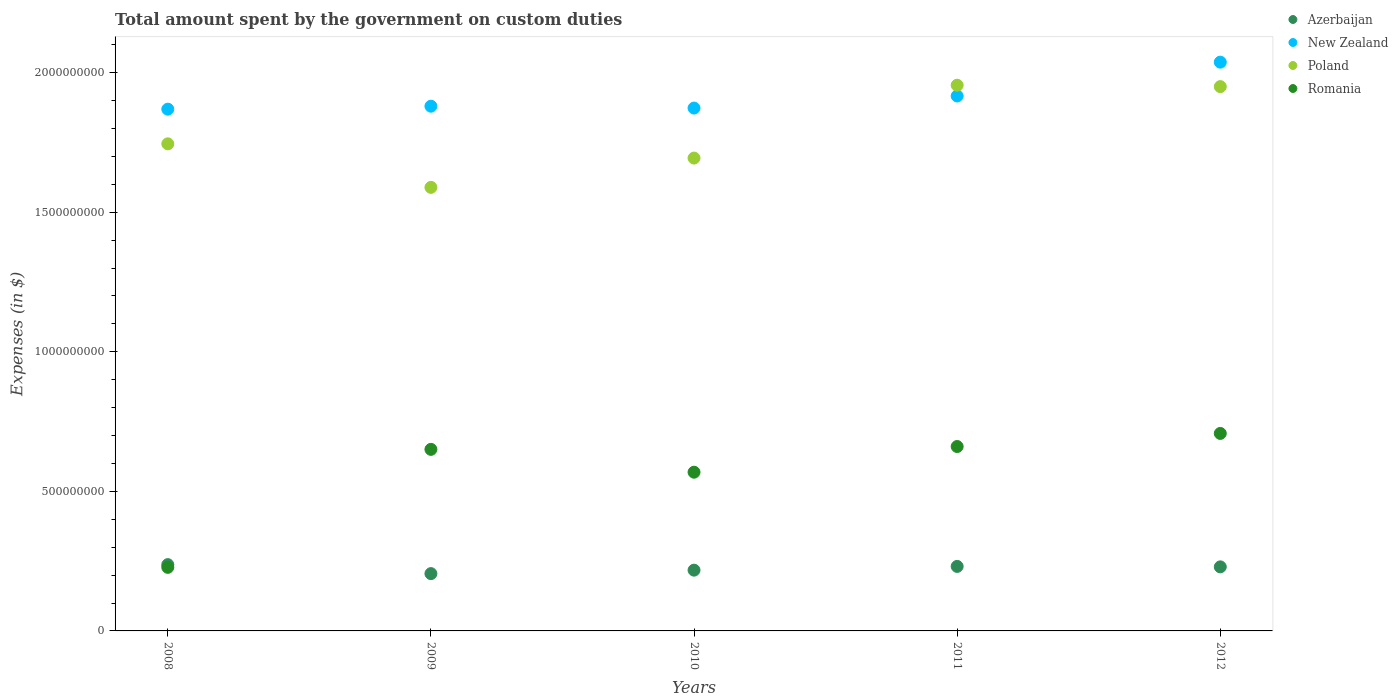Is the number of dotlines equal to the number of legend labels?
Keep it short and to the point. Yes. What is the amount spent on custom duties by the government in Romania in 2010?
Provide a succinct answer. 5.69e+08. Across all years, what is the maximum amount spent on custom duties by the government in New Zealand?
Give a very brief answer. 2.04e+09. Across all years, what is the minimum amount spent on custom duties by the government in Poland?
Your answer should be compact. 1.59e+09. In which year was the amount spent on custom duties by the government in Poland minimum?
Provide a succinct answer. 2009. What is the total amount spent on custom duties by the government in Azerbaijan in the graph?
Offer a terse response. 1.12e+09. What is the difference between the amount spent on custom duties by the government in Romania in 2008 and that in 2012?
Your response must be concise. -4.80e+08. What is the difference between the amount spent on custom duties by the government in New Zealand in 2011 and the amount spent on custom duties by the government in Romania in 2012?
Your answer should be very brief. 1.21e+09. What is the average amount spent on custom duties by the government in New Zealand per year?
Provide a short and direct response. 1.92e+09. In the year 2011, what is the difference between the amount spent on custom duties by the government in Romania and amount spent on custom duties by the government in Azerbaijan?
Your answer should be compact. 4.30e+08. In how many years, is the amount spent on custom duties by the government in New Zealand greater than 700000000 $?
Give a very brief answer. 5. What is the ratio of the amount spent on custom duties by the government in Romania in 2009 to that in 2011?
Provide a short and direct response. 0.98. What is the difference between the highest and the second highest amount spent on custom duties by the government in Azerbaijan?
Your answer should be very brief. 6.40e+06. What is the difference between the highest and the lowest amount spent on custom duties by the government in Romania?
Your response must be concise. 4.80e+08. Is it the case that in every year, the sum of the amount spent on custom duties by the government in Poland and amount spent on custom duties by the government in New Zealand  is greater than the amount spent on custom duties by the government in Romania?
Your response must be concise. Yes. How many dotlines are there?
Keep it short and to the point. 4. How many years are there in the graph?
Offer a very short reply. 5. Does the graph contain any zero values?
Keep it short and to the point. No. Does the graph contain grids?
Your response must be concise. No. What is the title of the graph?
Your answer should be compact. Total amount spent by the government on custom duties. Does "United Kingdom" appear as one of the legend labels in the graph?
Provide a short and direct response. No. What is the label or title of the X-axis?
Give a very brief answer. Years. What is the label or title of the Y-axis?
Provide a succinct answer. Expenses (in $). What is the Expenses (in $) of Azerbaijan in 2008?
Keep it short and to the point. 2.38e+08. What is the Expenses (in $) of New Zealand in 2008?
Offer a terse response. 1.87e+09. What is the Expenses (in $) in Poland in 2008?
Offer a very short reply. 1.74e+09. What is the Expenses (in $) of Romania in 2008?
Make the answer very short. 2.28e+08. What is the Expenses (in $) in Azerbaijan in 2009?
Give a very brief answer. 2.05e+08. What is the Expenses (in $) in New Zealand in 2009?
Make the answer very short. 1.88e+09. What is the Expenses (in $) in Poland in 2009?
Offer a terse response. 1.59e+09. What is the Expenses (in $) in Romania in 2009?
Offer a very short reply. 6.50e+08. What is the Expenses (in $) in Azerbaijan in 2010?
Provide a succinct answer. 2.18e+08. What is the Expenses (in $) of New Zealand in 2010?
Make the answer very short. 1.87e+09. What is the Expenses (in $) in Poland in 2010?
Your response must be concise. 1.69e+09. What is the Expenses (in $) of Romania in 2010?
Provide a short and direct response. 5.69e+08. What is the Expenses (in $) of Azerbaijan in 2011?
Give a very brief answer. 2.31e+08. What is the Expenses (in $) of New Zealand in 2011?
Offer a terse response. 1.92e+09. What is the Expenses (in $) in Poland in 2011?
Ensure brevity in your answer.  1.96e+09. What is the Expenses (in $) of Romania in 2011?
Give a very brief answer. 6.61e+08. What is the Expenses (in $) of Azerbaijan in 2012?
Your answer should be compact. 2.30e+08. What is the Expenses (in $) in New Zealand in 2012?
Give a very brief answer. 2.04e+09. What is the Expenses (in $) in Poland in 2012?
Your answer should be compact. 1.95e+09. What is the Expenses (in $) of Romania in 2012?
Offer a terse response. 7.08e+08. Across all years, what is the maximum Expenses (in $) in Azerbaijan?
Make the answer very short. 2.38e+08. Across all years, what is the maximum Expenses (in $) in New Zealand?
Provide a succinct answer. 2.04e+09. Across all years, what is the maximum Expenses (in $) in Poland?
Provide a short and direct response. 1.96e+09. Across all years, what is the maximum Expenses (in $) of Romania?
Your answer should be very brief. 7.08e+08. Across all years, what is the minimum Expenses (in $) in Azerbaijan?
Provide a succinct answer. 2.05e+08. Across all years, what is the minimum Expenses (in $) in New Zealand?
Your answer should be very brief. 1.87e+09. Across all years, what is the minimum Expenses (in $) of Poland?
Ensure brevity in your answer.  1.59e+09. Across all years, what is the minimum Expenses (in $) in Romania?
Make the answer very short. 2.28e+08. What is the total Expenses (in $) in Azerbaijan in the graph?
Give a very brief answer. 1.12e+09. What is the total Expenses (in $) of New Zealand in the graph?
Keep it short and to the point. 9.58e+09. What is the total Expenses (in $) of Poland in the graph?
Your answer should be very brief. 8.93e+09. What is the total Expenses (in $) of Romania in the graph?
Keep it short and to the point. 2.81e+09. What is the difference between the Expenses (in $) in Azerbaijan in 2008 and that in 2009?
Ensure brevity in your answer.  3.22e+07. What is the difference between the Expenses (in $) in New Zealand in 2008 and that in 2009?
Your answer should be very brief. -1.07e+07. What is the difference between the Expenses (in $) in Poland in 2008 and that in 2009?
Your answer should be very brief. 1.56e+08. What is the difference between the Expenses (in $) in Romania in 2008 and that in 2009?
Provide a short and direct response. -4.23e+08. What is the difference between the Expenses (in $) in Azerbaijan in 2008 and that in 2010?
Give a very brief answer. 1.98e+07. What is the difference between the Expenses (in $) of New Zealand in 2008 and that in 2010?
Your response must be concise. -3.96e+06. What is the difference between the Expenses (in $) of Poland in 2008 and that in 2010?
Your response must be concise. 5.10e+07. What is the difference between the Expenses (in $) in Romania in 2008 and that in 2010?
Your answer should be very brief. -3.41e+08. What is the difference between the Expenses (in $) in Azerbaijan in 2008 and that in 2011?
Give a very brief answer. 6.40e+06. What is the difference between the Expenses (in $) in New Zealand in 2008 and that in 2011?
Keep it short and to the point. -4.72e+07. What is the difference between the Expenses (in $) of Poland in 2008 and that in 2011?
Provide a succinct answer. -2.10e+08. What is the difference between the Expenses (in $) of Romania in 2008 and that in 2011?
Offer a very short reply. -4.33e+08. What is the difference between the Expenses (in $) of New Zealand in 2008 and that in 2012?
Make the answer very short. -1.68e+08. What is the difference between the Expenses (in $) of Poland in 2008 and that in 2012?
Offer a very short reply. -2.05e+08. What is the difference between the Expenses (in $) in Romania in 2008 and that in 2012?
Keep it short and to the point. -4.80e+08. What is the difference between the Expenses (in $) of Azerbaijan in 2009 and that in 2010?
Keep it short and to the point. -1.24e+07. What is the difference between the Expenses (in $) of New Zealand in 2009 and that in 2010?
Your answer should be very brief. 6.70e+06. What is the difference between the Expenses (in $) in Poland in 2009 and that in 2010?
Offer a very short reply. -1.05e+08. What is the difference between the Expenses (in $) in Romania in 2009 and that in 2010?
Offer a very short reply. 8.18e+07. What is the difference between the Expenses (in $) of Azerbaijan in 2009 and that in 2011?
Offer a terse response. -2.58e+07. What is the difference between the Expenses (in $) of New Zealand in 2009 and that in 2011?
Make the answer very short. -3.65e+07. What is the difference between the Expenses (in $) of Poland in 2009 and that in 2011?
Your answer should be compact. -3.66e+08. What is the difference between the Expenses (in $) in Romania in 2009 and that in 2011?
Your answer should be very brief. -1.02e+07. What is the difference between the Expenses (in $) in Azerbaijan in 2009 and that in 2012?
Give a very brief answer. -2.42e+07. What is the difference between the Expenses (in $) of New Zealand in 2009 and that in 2012?
Give a very brief answer. -1.58e+08. What is the difference between the Expenses (in $) of Poland in 2009 and that in 2012?
Ensure brevity in your answer.  -3.61e+08. What is the difference between the Expenses (in $) of Romania in 2009 and that in 2012?
Provide a succinct answer. -5.71e+07. What is the difference between the Expenses (in $) in Azerbaijan in 2010 and that in 2011?
Give a very brief answer. -1.34e+07. What is the difference between the Expenses (in $) in New Zealand in 2010 and that in 2011?
Your response must be concise. -4.32e+07. What is the difference between the Expenses (in $) of Poland in 2010 and that in 2011?
Provide a succinct answer. -2.61e+08. What is the difference between the Expenses (in $) of Romania in 2010 and that in 2011?
Provide a succinct answer. -9.20e+07. What is the difference between the Expenses (in $) in Azerbaijan in 2010 and that in 2012?
Provide a short and direct response. -1.18e+07. What is the difference between the Expenses (in $) in New Zealand in 2010 and that in 2012?
Your response must be concise. -1.65e+08. What is the difference between the Expenses (in $) in Poland in 2010 and that in 2012?
Your response must be concise. -2.56e+08. What is the difference between the Expenses (in $) of Romania in 2010 and that in 2012?
Make the answer very short. -1.39e+08. What is the difference between the Expenses (in $) in Azerbaijan in 2011 and that in 2012?
Your answer should be very brief. 1.60e+06. What is the difference between the Expenses (in $) of New Zealand in 2011 and that in 2012?
Your answer should be compact. -1.21e+08. What is the difference between the Expenses (in $) in Poland in 2011 and that in 2012?
Your answer should be very brief. 5.00e+06. What is the difference between the Expenses (in $) of Romania in 2011 and that in 2012?
Ensure brevity in your answer.  -4.69e+07. What is the difference between the Expenses (in $) of Azerbaijan in 2008 and the Expenses (in $) of New Zealand in 2009?
Give a very brief answer. -1.64e+09. What is the difference between the Expenses (in $) of Azerbaijan in 2008 and the Expenses (in $) of Poland in 2009?
Offer a very short reply. -1.35e+09. What is the difference between the Expenses (in $) of Azerbaijan in 2008 and the Expenses (in $) of Romania in 2009?
Offer a very short reply. -4.13e+08. What is the difference between the Expenses (in $) of New Zealand in 2008 and the Expenses (in $) of Poland in 2009?
Provide a succinct answer. 2.80e+08. What is the difference between the Expenses (in $) of New Zealand in 2008 and the Expenses (in $) of Romania in 2009?
Your answer should be compact. 1.22e+09. What is the difference between the Expenses (in $) of Poland in 2008 and the Expenses (in $) of Romania in 2009?
Provide a short and direct response. 1.09e+09. What is the difference between the Expenses (in $) of Azerbaijan in 2008 and the Expenses (in $) of New Zealand in 2010?
Offer a very short reply. -1.64e+09. What is the difference between the Expenses (in $) of Azerbaijan in 2008 and the Expenses (in $) of Poland in 2010?
Your response must be concise. -1.46e+09. What is the difference between the Expenses (in $) of Azerbaijan in 2008 and the Expenses (in $) of Romania in 2010?
Keep it short and to the point. -3.31e+08. What is the difference between the Expenses (in $) of New Zealand in 2008 and the Expenses (in $) of Poland in 2010?
Give a very brief answer. 1.75e+08. What is the difference between the Expenses (in $) in New Zealand in 2008 and the Expenses (in $) in Romania in 2010?
Your response must be concise. 1.30e+09. What is the difference between the Expenses (in $) of Poland in 2008 and the Expenses (in $) of Romania in 2010?
Your answer should be compact. 1.18e+09. What is the difference between the Expenses (in $) in Azerbaijan in 2008 and the Expenses (in $) in New Zealand in 2011?
Your answer should be very brief. -1.68e+09. What is the difference between the Expenses (in $) of Azerbaijan in 2008 and the Expenses (in $) of Poland in 2011?
Your answer should be compact. -1.72e+09. What is the difference between the Expenses (in $) in Azerbaijan in 2008 and the Expenses (in $) in Romania in 2011?
Give a very brief answer. -4.23e+08. What is the difference between the Expenses (in $) in New Zealand in 2008 and the Expenses (in $) in Poland in 2011?
Your answer should be compact. -8.58e+07. What is the difference between the Expenses (in $) in New Zealand in 2008 and the Expenses (in $) in Romania in 2011?
Your answer should be compact. 1.21e+09. What is the difference between the Expenses (in $) in Poland in 2008 and the Expenses (in $) in Romania in 2011?
Give a very brief answer. 1.08e+09. What is the difference between the Expenses (in $) of Azerbaijan in 2008 and the Expenses (in $) of New Zealand in 2012?
Offer a very short reply. -1.80e+09. What is the difference between the Expenses (in $) of Azerbaijan in 2008 and the Expenses (in $) of Poland in 2012?
Provide a succinct answer. -1.71e+09. What is the difference between the Expenses (in $) in Azerbaijan in 2008 and the Expenses (in $) in Romania in 2012?
Keep it short and to the point. -4.70e+08. What is the difference between the Expenses (in $) of New Zealand in 2008 and the Expenses (in $) of Poland in 2012?
Offer a very short reply. -8.08e+07. What is the difference between the Expenses (in $) in New Zealand in 2008 and the Expenses (in $) in Romania in 2012?
Your response must be concise. 1.16e+09. What is the difference between the Expenses (in $) in Poland in 2008 and the Expenses (in $) in Romania in 2012?
Keep it short and to the point. 1.04e+09. What is the difference between the Expenses (in $) in Azerbaijan in 2009 and the Expenses (in $) in New Zealand in 2010?
Offer a very short reply. -1.67e+09. What is the difference between the Expenses (in $) of Azerbaijan in 2009 and the Expenses (in $) of Poland in 2010?
Make the answer very short. -1.49e+09. What is the difference between the Expenses (in $) of Azerbaijan in 2009 and the Expenses (in $) of Romania in 2010?
Your answer should be very brief. -3.63e+08. What is the difference between the Expenses (in $) of New Zealand in 2009 and the Expenses (in $) of Poland in 2010?
Your response must be concise. 1.86e+08. What is the difference between the Expenses (in $) of New Zealand in 2009 and the Expenses (in $) of Romania in 2010?
Ensure brevity in your answer.  1.31e+09. What is the difference between the Expenses (in $) in Poland in 2009 and the Expenses (in $) in Romania in 2010?
Your answer should be compact. 1.02e+09. What is the difference between the Expenses (in $) of Azerbaijan in 2009 and the Expenses (in $) of New Zealand in 2011?
Provide a short and direct response. -1.71e+09. What is the difference between the Expenses (in $) of Azerbaijan in 2009 and the Expenses (in $) of Poland in 2011?
Give a very brief answer. -1.75e+09. What is the difference between the Expenses (in $) in Azerbaijan in 2009 and the Expenses (in $) in Romania in 2011?
Offer a very short reply. -4.55e+08. What is the difference between the Expenses (in $) of New Zealand in 2009 and the Expenses (in $) of Poland in 2011?
Keep it short and to the point. -7.52e+07. What is the difference between the Expenses (in $) in New Zealand in 2009 and the Expenses (in $) in Romania in 2011?
Keep it short and to the point. 1.22e+09. What is the difference between the Expenses (in $) in Poland in 2009 and the Expenses (in $) in Romania in 2011?
Offer a very short reply. 9.28e+08. What is the difference between the Expenses (in $) of Azerbaijan in 2009 and the Expenses (in $) of New Zealand in 2012?
Your answer should be compact. -1.83e+09. What is the difference between the Expenses (in $) in Azerbaijan in 2009 and the Expenses (in $) in Poland in 2012?
Offer a terse response. -1.74e+09. What is the difference between the Expenses (in $) in Azerbaijan in 2009 and the Expenses (in $) in Romania in 2012?
Offer a terse response. -5.02e+08. What is the difference between the Expenses (in $) of New Zealand in 2009 and the Expenses (in $) of Poland in 2012?
Your answer should be very brief. -7.02e+07. What is the difference between the Expenses (in $) in New Zealand in 2009 and the Expenses (in $) in Romania in 2012?
Offer a very short reply. 1.17e+09. What is the difference between the Expenses (in $) in Poland in 2009 and the Expenses (in $) in Romania in 2012?
Your answer should be compact. 8.81e+08. What is the difference between the Expenses (in $) of Azerbaijan in 2010 and the Expenses (in $) of New Zealand in 2011?
Give a very brief answer. -1.70e+09. What is the difference between the Expenses (in $) in Azerbaijan in 2010 and the Expenses (in $) in Poland in 2011?
Keep it short and to the point. -1.74e+09. What is the difference between the Expenses (in $) of Azerbaijan in 2010 and the Expenses (in $) of Romania in 2011?
Keep it short and to the point. -4.43e+08. What is the difference between the Expenses (in $) in New Zealand in 2010 and the Expenses (in $) in Poland in 2011?
Your response must be concise. -8.19e+07. What is the difference between the Expenses (in $) in New Zealand in 2010 and the Expenses (in $) in Romania in 2011?
Your answer should be compact. 1.21e+09. What is the difference between the Expenses (in $) of Poland in 2010 and the Expenses (in $) of Romania in 2011?
Make the answer very short. 1.03e+09. What is the difference between the Expenses (in $) of Azerbaijan in 2010 and the Expenses (in $) of New Zealand in 2012?
Your answer should be compact. -1.82e+09. What is the difference between the Expenses (in $) of Azerbaijan in 2010 and the Expenses (in $) of Poland in 2012?
Offer a very short reply. -1.73e+09. What is the difference between the Expenses (in $) of Azerbaijan in 2010 and the Expenses (in $) of Romania in 2012?
Provide a succinct answer. -4.90e+08. What is the difference between the Expenses (in $) in New Zealand in 2010 and the Expenses (in $) in Poland in 2012?
Give a very brief answer. -7.69e+07. What is the difference between the Expenses (in $) in New Zealand in 2010 and the Expenses (in $) in Romania in 2012?
Your answer should be very brief. 1.17e+09. What is the difference between the Expenses (in $) in Poland in 2010 and the Expenses (in $) in Romania in 2012?
Your response must be concise. 9.86e+08. What is the difference between the Expenses (in $) in Azerbaijan in 2011 and the Expenses (in $) in New Zealand in 2012?
Keep it short and to the point. -1.81e+09. What is the difference between the Expenses (in $) of Azerbaijan in 2011 and the Expenses (in $) of Poland in 2012?
Keep it short and to the point. -1.72e+09. What is the difference between the Expenses (in $) in Azerbaijan in 2011 and the Expenses (in $) in Romania in 2012?
Provide a succinct answer. -4.76e+08. What is the difference between the Expenses (in $) of New Zealand in 2011 and the Expenses (in $) of Poland in 2012?
Your answer should be very brief. -3.36e+07. What is the difference between the Expenses (in $) of New Zealand in 2011 and the Expenses (in $) of Romania in 2012?
Offer a terse response. 1.21e+09. What is the difference between the Expenses (in $) of Poland in 2011 and the Expenses (in $) of Romania in 2012?
Offer a terse response. 1.25e+09. What is the average Expenses (in $) in Azerbaijan per year?
Provide a short and direct response. 2.24e+08. What is the average Expenses (in $) of New Zealand per year?
Offer a very short reply. 1.92e+09. What is the average Expenses (in $) in Poland per year?
Offer a very short reply. 1.79e+09. What is the average Expenses (in $) of Romania per year?
Make the answer very short. 5.63e+08. In the year 2008, what is the difference between the Expenses (in $) of Azerbaijan and Expenses (in $) of New Zealand?
Keep it short and to the point. -1.63e+09. In the year 2008, what is the difference between the Expenses (in $) in Azerbaijan and Expenses (in $) in Poland?
Provide a succinct answer. -1.51e+09. In the year 2008, what is the difference between the Expenses (in $) of Azerbaijan and Expenses (in $) of Romania?
Make the answer very short. 9.78e+06. In the year 2008, what is the difference between the Expenses (in $) of New Zealand and Expenses (in $) of Poland?
Keep it short and to the point. 1.24e+08. In the year 2008, what is the difference between the Expenses (in $) of New Zealand and Expenses (in $) of Romania?
Your answer should be very brief. 1.64e+09. In the year 2008, what is the difference between the Expenses (in $) of Poland and Expenses (in $) of Romania?
Offer a very short reply. 1.52e+09. In the year 2009, what is the difference between the Expenses (in $) of Azerbaijan and Expenses (in $) of New Zealand?
Ensure brevity in your answer.  -1.67e+09. In the year 2009, what is the difference between the Expenses (in $) in Azerbaijan and Expenses (in $) in Poland?
Make the answer very short. -1.38e+09. In the year 2009, what is the difference between the Expenses (in $) of Azerbaijan and Expenses (in $) of Romania?
Provide a short and direct response. -4.45e+08. In the year 2009, what is the difference between the Expenses (in $) in New Zealand and Expenses (in $) in Poland?
Provide a succinct answer. 2.91e+08. In the year 2009, what is the difference between the Expenses (in $) in New Zealand and Expenses (in $) in Romania?
Ensure brevity in your answer.  1.23e+09. In the year 2009, what is the difference between the Expenses (in $) of Poland and Expenses (in $) of Romania?
Your response must be concise. 9.39e+08. In the year 2010, what is the difference between the Expenses (in $) of Azerbaijan and Expenses (in $) of New Zealand?
Offer a terse response. -1.66e+09. In the year 2010, what is the difference between the Expenses (in $) of Azerbaijan and Expenses (in $) of Poland?
Offer a terse response. -1.48e+09. In the year 2010, what is the difference between the Expenses (in $) of Azerbaijan and Expenses (in $) of Romania?
Your response must be concise. -3.51e+08. In the year 2010, what is the difference between the Expenses (in $) of New Zealand and Expenses (in $) of Poland?
Give a very brief answer. 1.79e+08. In the year 2010, what is the difference between the Expenses (in $) in New Zealand and Expenses (in $) in Romania?
Give a very brief answer. 1.30e+09. In the year 2010, what is the difference between the Expenses (in $) of Poland and Expenses (in $) of Romania?
Ensure brevity in your answer.  1.13e+09. In the year 2011, what is the difference between the Expenses (in $) of Azerbaijan and Expenses (in $) of New Zealand?
Provide a short and direct response. -1.69e+09. In the year 2011, what is the difference between the Expenses (in $) in Azerbaijan and Expenses (in $) in Poland?
Provide a succinct answer. -1.72e+09. In the year 2011, what is the difference between the Expenses (in $) of Azerbaijan and Expenses (in $) of Romania?
Offer a very short reply. -4.30e+08. In the year 2011, what is the difference between the Expenses (in $) in New Zealand and Expenses (in $) in Poland?
Ensure brevity in your answer.  -3.86e+07. In the year 2011, what is the difference between the Expenses (in $) in New Zealand and Expenses (in $) in Romania?
Ensure brevity in your answer.  1.26e+09. In the year 2011, what is the difference between the Expenses (in $) in Poland and Expenses (in $) in Romania?
Offer a very short reply. 1.29e+09. In the year 2012, what is the difference between the Expenses (in $) of Azerbaijan and Expenses (in $) of New Zealand?
Ensure brevity in your answer.  -1.81e+09. In the year 2012, what is the difference between the Expenses (in $) in Azerbaijan and Expenses (in $) in Poland?
Offer a terse response. -1.72e+09. In the year 2012, what is the difference between the Expenses (in $) in Azerbaijan and Expenses (in $) in Romania?
Your answer should be compact. -4.78e+08. In the year 2012, what is the difference between the Expenses (in $) of New Zealand and Expenses (in $) of Poland?
Provide a short and direct response. 8.76e+07. In the year 2012, what is the difference between the Expenses (in $) of New Zealand and Expenses (in $) of Romania?
Give a very brief answer. 1.33e+09. In the year 2012, what is the difference between the Expenses (in $) in Poland and Expenses (in $) in Romania?
Offer a terse response. 1.24e+09. What is the ratio of the Expenses (in $) of Azerbaijan in 2008 to that in 2009?
Keep it short and to the point. 1.16. What is the ratio of the Expenses (in $) in New Zealand in 2008 to that in 2009?
Keep it short and to the point. 0.99. What is the ratio of the Expenses (in $) of Poland in 2008 to that in 2009?
Keep it short and to the point. 1.1. What is the ratio of the Expenses (in $) in Romania in 2008 to that in 2009?
Your answer should be very brief. 0.35. What is the ratio of the Expenses (in $) of Azerbaijan in 2008 to that in 2010?
Ensure brevity in your answer.  1.09. What is the ratio of the Expenses (in $) in Poland in 2008 to that in 2010?
Your answer should be very brief. 1.03. What is the ratio of the Expenses (in $) in Romania in 2008 to that in 2010?
Provide a short and direct response. 0.4. What is the ratio of the Expenses (in $) in Azerbaijan in 2008 to that in 2011?
Keep it short and to the point. 1.03. What is the ratio of the Expenses (in $) in New Zealand in 2008 to that in 2011?
Your answer should be very brief. 0.98. What is the ratio of the Expenses (in $) of Poland in 2008 to that in 2011?
Offer a very short reply. 0.89. What is the ratio of the Expenses (in $) of Romania in 2008 to that in 2011?
Your answer should be compact. 0.34. What is the ratio of the Expenses (in $) in Azerbaijan in 2008 to that in 2012?
Make the answer very short. 1.03. What is the ratio of the Expenses (in $) in New Zealand in 2008 to that in 2012?
Give a very brief answer. 0.92. What is the ratio of the Expenses (in $) in Poland in 2008 to that in 2012?
Offer a very short reply. 0.89. What is the ratio of the Expenses (in $) in Romania in 2008 to that in 2012?
Ensure brevity in your answer.  0.32. What is the ratio of the Expenses (in $) in Azerbaijan in 2009 to that in 2010?
Give a very brief answer. 0.94. What is the ratio of the Expenses (in $) in Poland in 2009 to that in 2010?
Your answer should be compact. 0.94. What is the ratio of the Expenses (in $) of Romania in 2009 to that in 2010?
Your answer should be very brief. 1.14. What is the ratio of the Expenses (in $) in Azerbaijan in 2009 to that in 2011?
Keep it short and to the point. 0.89. What is the ratio of the Expenses (in $) of New Zealand in 2009 to that in 2011?
Keep it short and to the point. 0.98. What is the ratio of the Expenses (in $) of Poland in 2009 to that in 2011?
Your answer should be compact. 0.81. What is the ratio of the Expenses (in $) in Romania in 2009 to that in 2011?
Provide a succinct answer. 0.98. What is the ratio of the Expenses (in $) in Azerbaijan in 2009 to that in 2012?
Your answer should be compact. 0.89. What is the ratio of the Expenses (in $) in New Zealand in 2009 to that in 2012?
Provide a succinct answer. 0.92. What is the ratio of the Expenses (in $) in Poland in 2009 to that in 2012?
Provide a succinct answer. 0.81. What is the ratio of the Expenses (in $) of Romania in 2009 to that in 2012?
Your answer should be compact. 0.92. What is the ratio of the Expenses (in $) in Azerbaijan in 2010 to that in 2011?
Keep it short and to the point. 0.94. What is the ratio of the Expenses (in $) in New Zealand in 2010 to that in 2011?
Your answer should be compact. 0.98. What is the ratio of the Expenses (in $) of Poland in 2010 to that in 2011?
Keep it short and to the point. 0.87. What is the ratio of the Expenses (in $) in Romania in 2010 to that in 2011?
Your answer should be very brief. 0.86. What is the ratio of the Expenses (in $) in Azerbaijan in 2010 to that in 2012?
Provide a short and direct response. 0.95. What is the ratio of the Expenses (in $) in New Zealand in 2010 to that in 2012?
Provide a succinct answer. 0.92. What is the ratio of the Expenses (in $) of Poland in 2010 to that in 2012?
Provide a short and direct response. 0.87. What is the ratio of the Expenses (in $) of Romania in 2010 to that in 2012?
Keep it short and to the point. 0.8. What is the ratio of the Expenses (in $) of Azerbaijan in 2011 to that in 2012?
Make the answer very short. 1.01. What is the ratio of the Expenses (in $) in New Zealand in 2011 to that in 2012?
Offer a very short reply. 0.94. What is the ratio of the Expenses (in $) of Romania in 2011 to that in 2012?
Make the answer very short. 0.93. What is the difference between the highest and the second highest Expenses (in $) of Azerbaijan?
Keep it short and to the point. 6.40e+06. What is the difference between the highest and the second highest Expenses (in $) of New Zealand?
Offer a terse response. 1.21e+08. What is the difference between the highest and the second highest Expenses (in $) of Poland?
Offer a very short reply. 5.00e+06. What is the difference between the highest and the second highest Expenses (in $) in Romania?
Keep it short and to the point. 4.69e+07. What is the difference between the highest and the lowest Expenses (in $) of Azerbaijan?
Keep it short and to the point. 3.22e+07. What is the difference between the highest and the lowest Expenses (in $) of New Zealand?
Your response must be concise. 1.68e+08. What is the difference between the highest and the lowest Expenses (in $) of Poland?
Your response must be concise. 3.66e+08. What is the difference between the highest and the lowest Expenses (in $) in Romania?
Your response must be concise. 4.80e+08. 